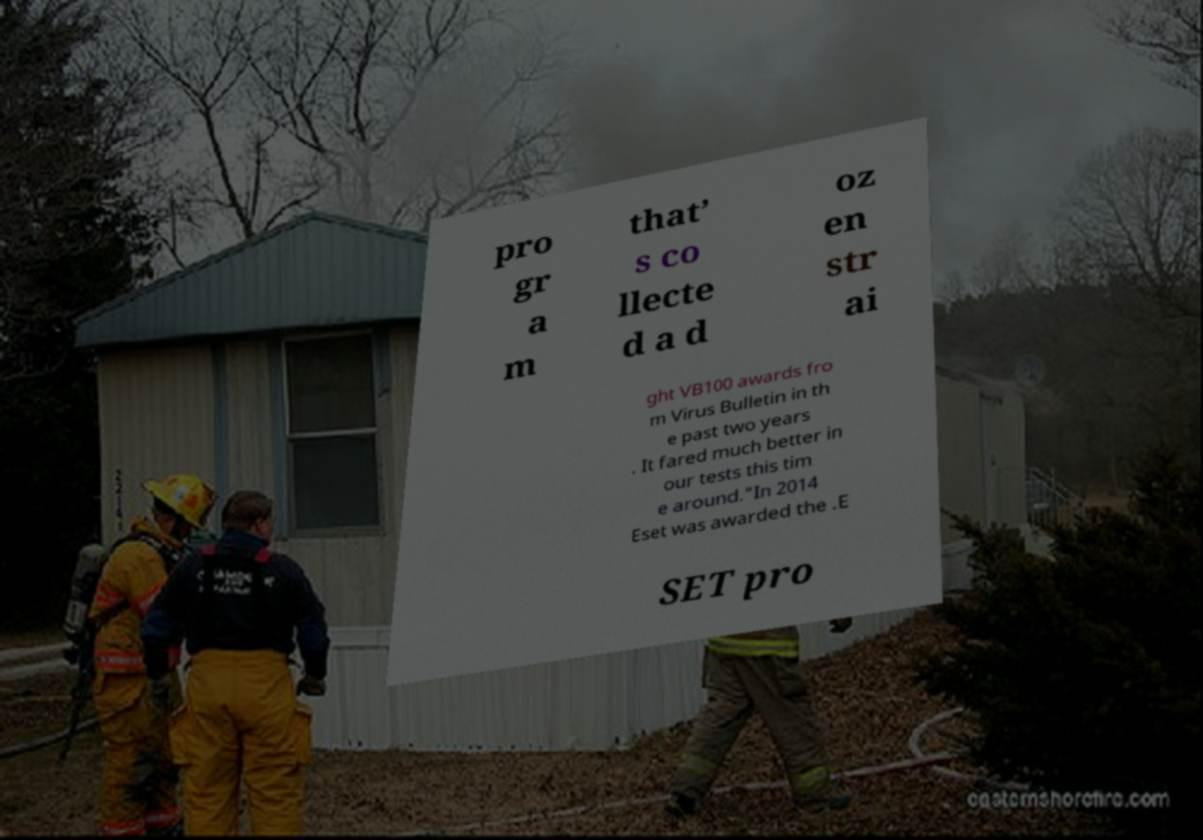Can you accurately transcribe the text from the provided image for me? pro gr a m that’ s co llecte d a d oz en str ai ght VB100 awards fro m Virus Bulletin in th e past two years . It fared much better in our tests this tim e around."In 2014 Eset was awarded the .E SET pro 